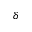Convert formula to latex. <formula><loc_0><loc_0><loc_500><loc_500>\delta</formula> 